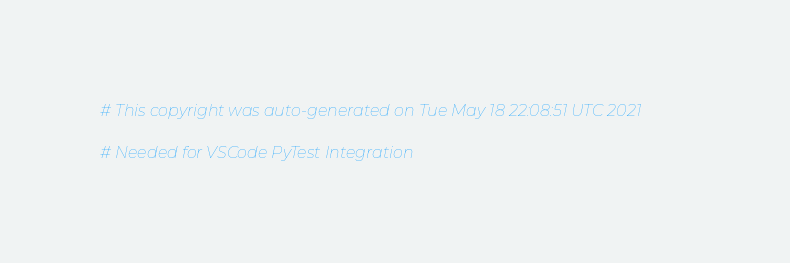Convert code to text. <code><loc_0><loc_0><loc_500><loc_500><_Python_># This copyright was auto-generated on Tue May 18 22:08:51 UTC 2021

# Needed for VSCode PyTest Integration
</code> 